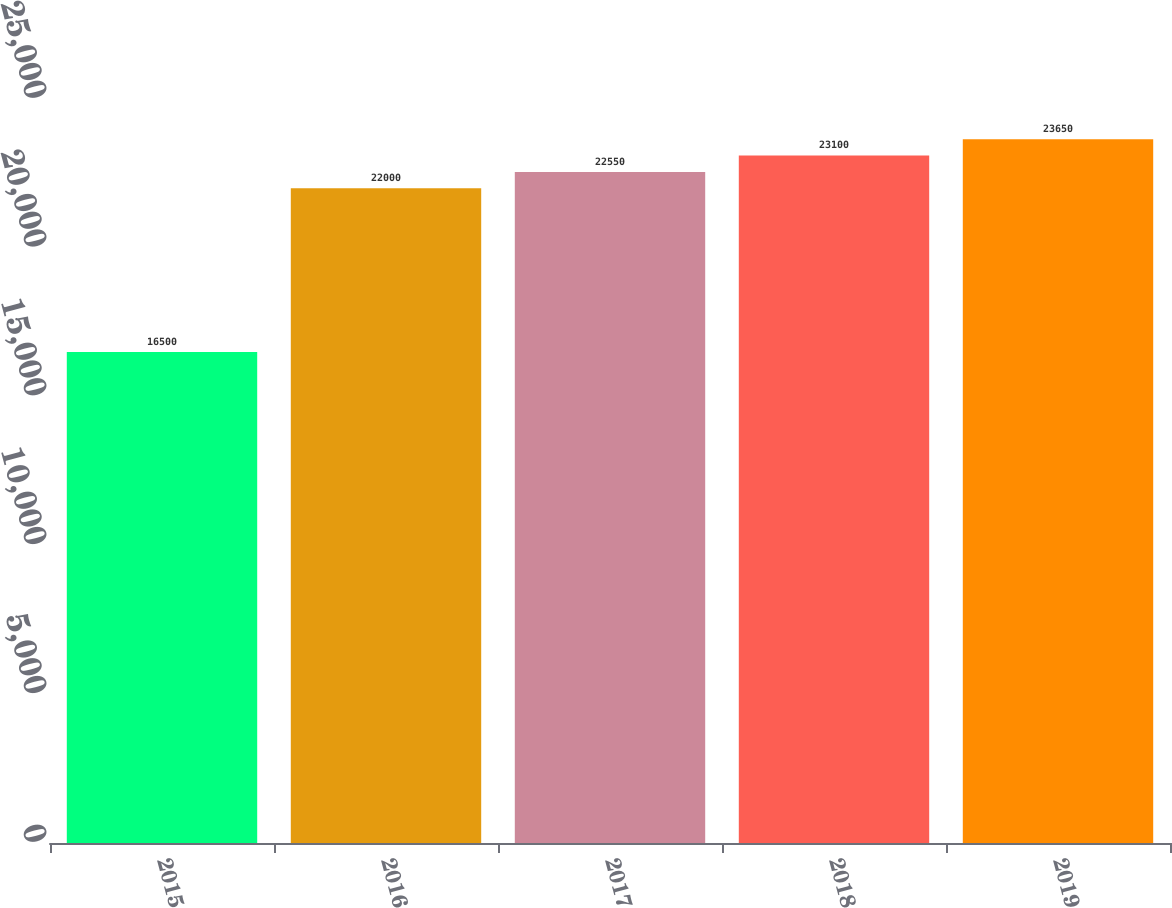Convert chart. <chart><loc_0><loc_0><loc_500><loc_500><bar_chart><fcel>2015<fcel>2016<fcel>2017<fcel>2018<fcel>2019<nl><fcel>16500<fcel>22000<fcel>22550<fcel>23100<fcel>23650<nl></chart> 